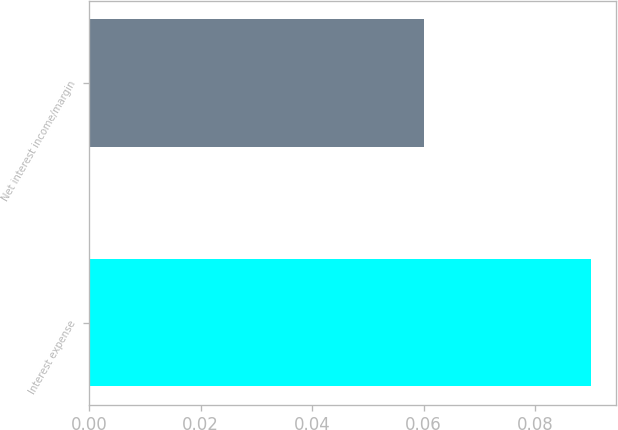Convert chart to OTSL. <chart><loc_0><loc_0><loc_500><loc_500><bar_chart><fcel>Interest expense<fcel>Net interest income/margin<nl><fcel>0.09<fcel>0.06<nl></chart> 